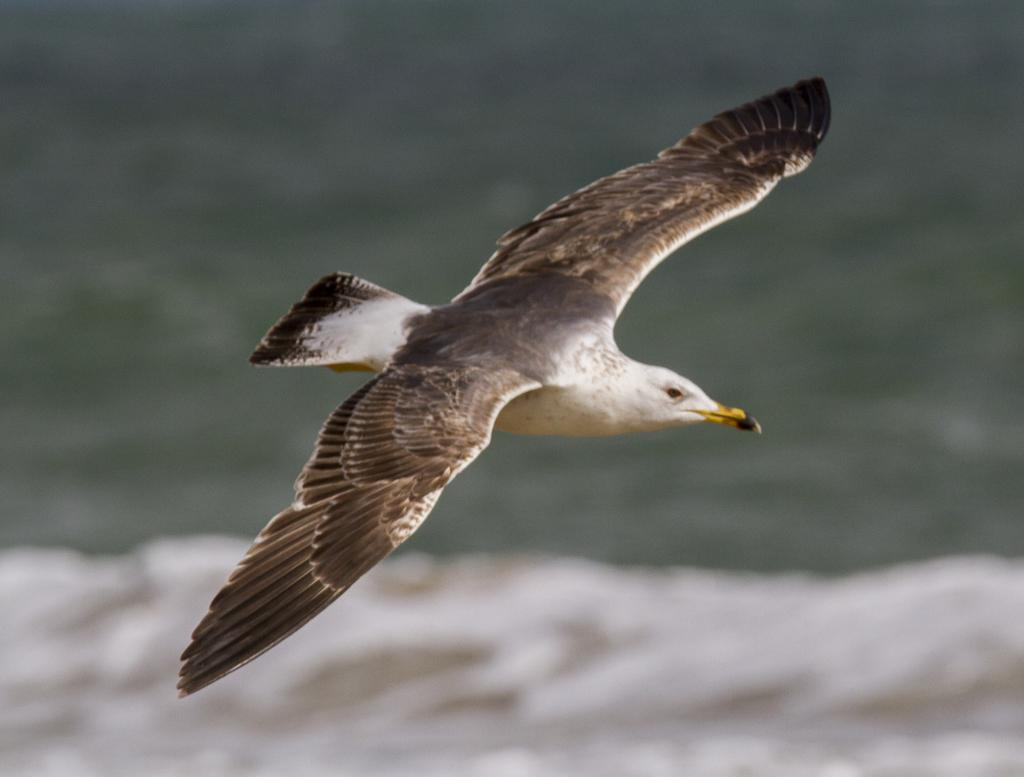What type of animal can be seen in the image? There is a bird in the image. What color combination is used for the bird? The bird is in black and white color combination. What is the bird doing in the image? The bird is flying in the air. Can you describe the background of the image? The background of the image is blurred. What type of fruit is the bird holding in its beak in the image? There is no fruit present in the image, and the bird is not holding anything in its beak. 